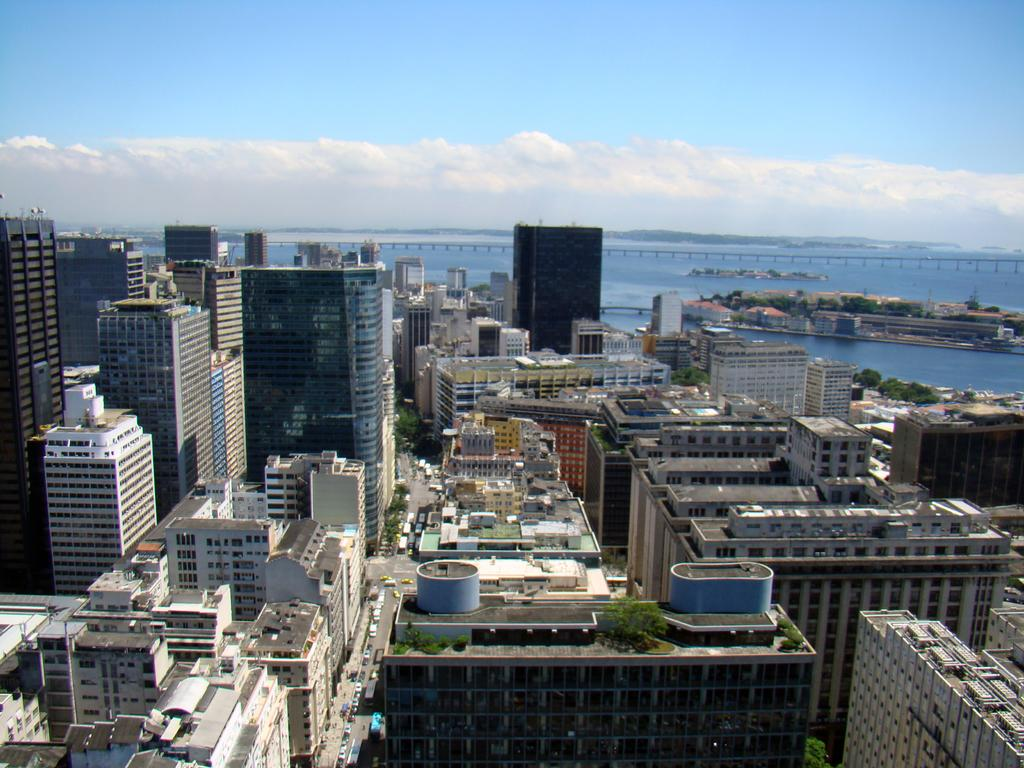What type of structures can be seen in the image? There are many buildings in the image. What natural element is present in the image? There is water in the image. What is visible at the top of the image? The sky is visible at the top of the image. What type of vegetation can be seen in the image? There are trees in the image. What type of man-made objects can be seen in the image? There are vehicles in the image. Can you tell me how many keys are hanging from the wax in the image? There is no wax or keys present in the image. What type of request is being made in the image? There is no request being made in the image. 